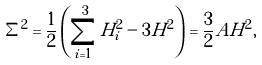<formula> <loc_0><loc_0><loc_500><loc_500>\Sigma ^ { 2 } = \frac { 1 } { 2 } \left ( \sum _ { i = 1 } ^ { 3 } H _ { i } ^ { 2 } - 3 H ^ { 2 } \right ) = \frac { 3 } { 2 } A H ^ { 2 } ,</formula> 